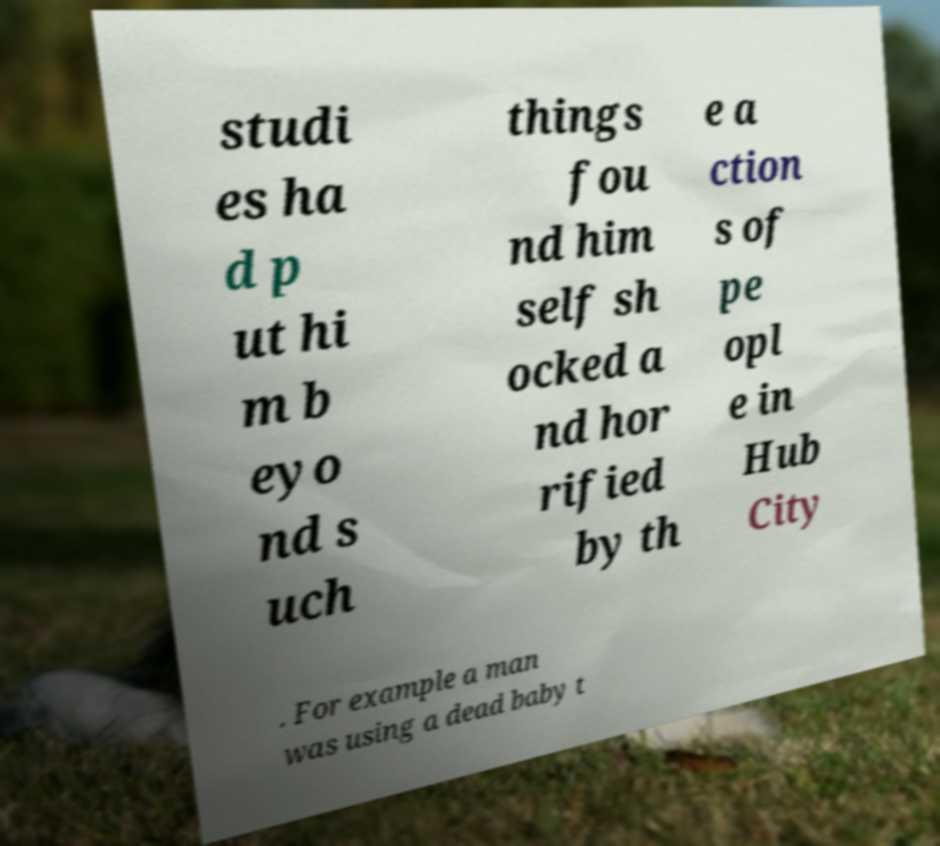What messages or text are displayed in this image? I need them in a readable, typed format. studi es ha d p ut hi m b eyo nd s uch things fou nd him self sh ocked a nd hor rified by th e a ction s of pe opl e in Hub City . For example a man was using a dead baby t 